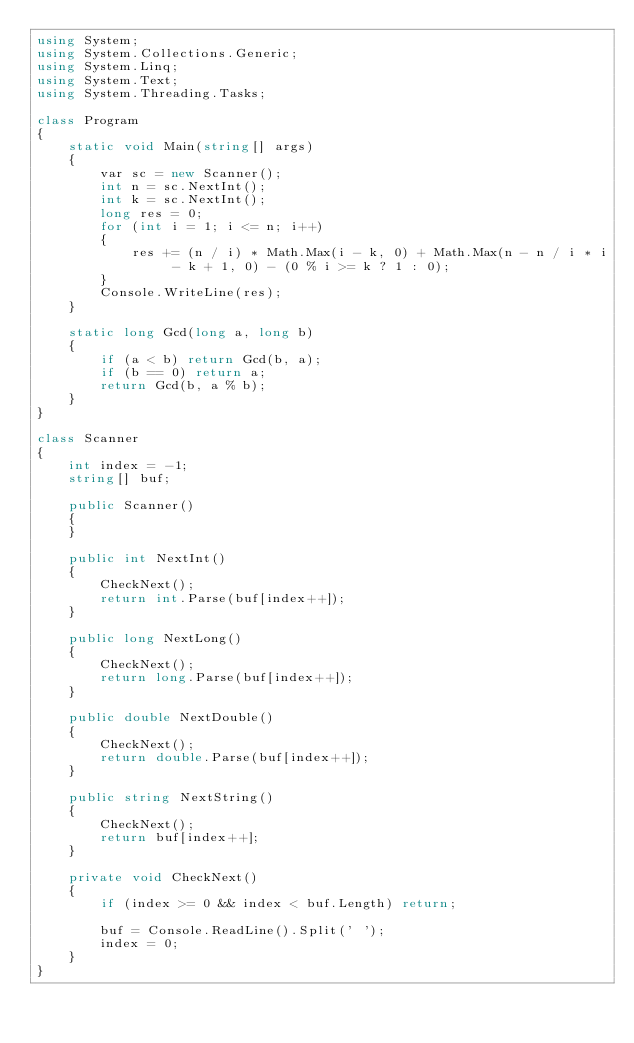Convert code to text. <code><loc_0><loc_0><loc_500><loc_500><_C#_>using System;
using System.Collections.Generic;
using System.Linq;
using System.Text;
using System.Threading.Tasks;

class Program
{
    static void Main(string[] args)
    {
        var sc = new Scanner();
        int n = sc.NextInt();
        int k = sc.NextInt();
        long res = 0;
        for (int i = 1; i <= n; i++)
        {
            res += (n / i) * Math.Max(i - k, 0) + Math.Max(n - n / i * i - k + 1, 0) - (0 % i >= k ? 1 : 0);
        }
        Console.WriteLine(res);
    }

    static long Gcd(long a, long b)
    {
        if (a < b) return Gcd(b, a);
        if (b == 0) return a;
        return Gcd(b, a % b);
    }
}

class Scanner
{
    int index = -1;
    string[] buf;

    public Scanner()
    {
    }

    public int NextInt()
    {
        CheckNext();
        return int.Parse(buf[index++]);
    }

    public long NextLong()
    {
        CheckNext();
        return long.Parse(buf[index++]);
    }

    public double NextDouble()
    {
        CheckNext();
        return double.Parse(buf[index++]);
    }

    public string NextString()
    {
        CheckNext();
        return buf[index++];
    }

    private void CheckNext()
    {
        if (index >= 0 && index < buf.Length) return;

        buf = Console.ReadLine().Split(' ');
        index = 0;
    }
}
</code> 